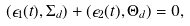<formula> <loc_0><loc_0><loc_500><loc_500>( \epsilon _ { 1 } ( t ) , \Sigma _ { d } ) + ( \epsilon _ { 2 } ( t ) , \Theta _ { d } ) = 0 ,</formula> 